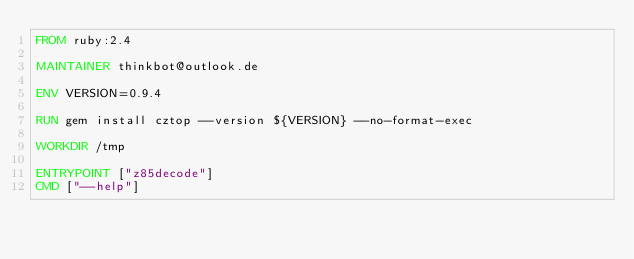Convert code to text. <code><loc_0><loc_0><loc_500><loc_500><_Dockerfile_>FROM ruby:2.4

MAINTAINER thinkbot@outlook.de

ENV VERSION=0.9.4

RUN gem install cztop --version ${VERSION} --no-format-exec

WORKDIR /tmp

ENTRYPOINT ["z85decode"]
CMD ["--help"]
</code> 